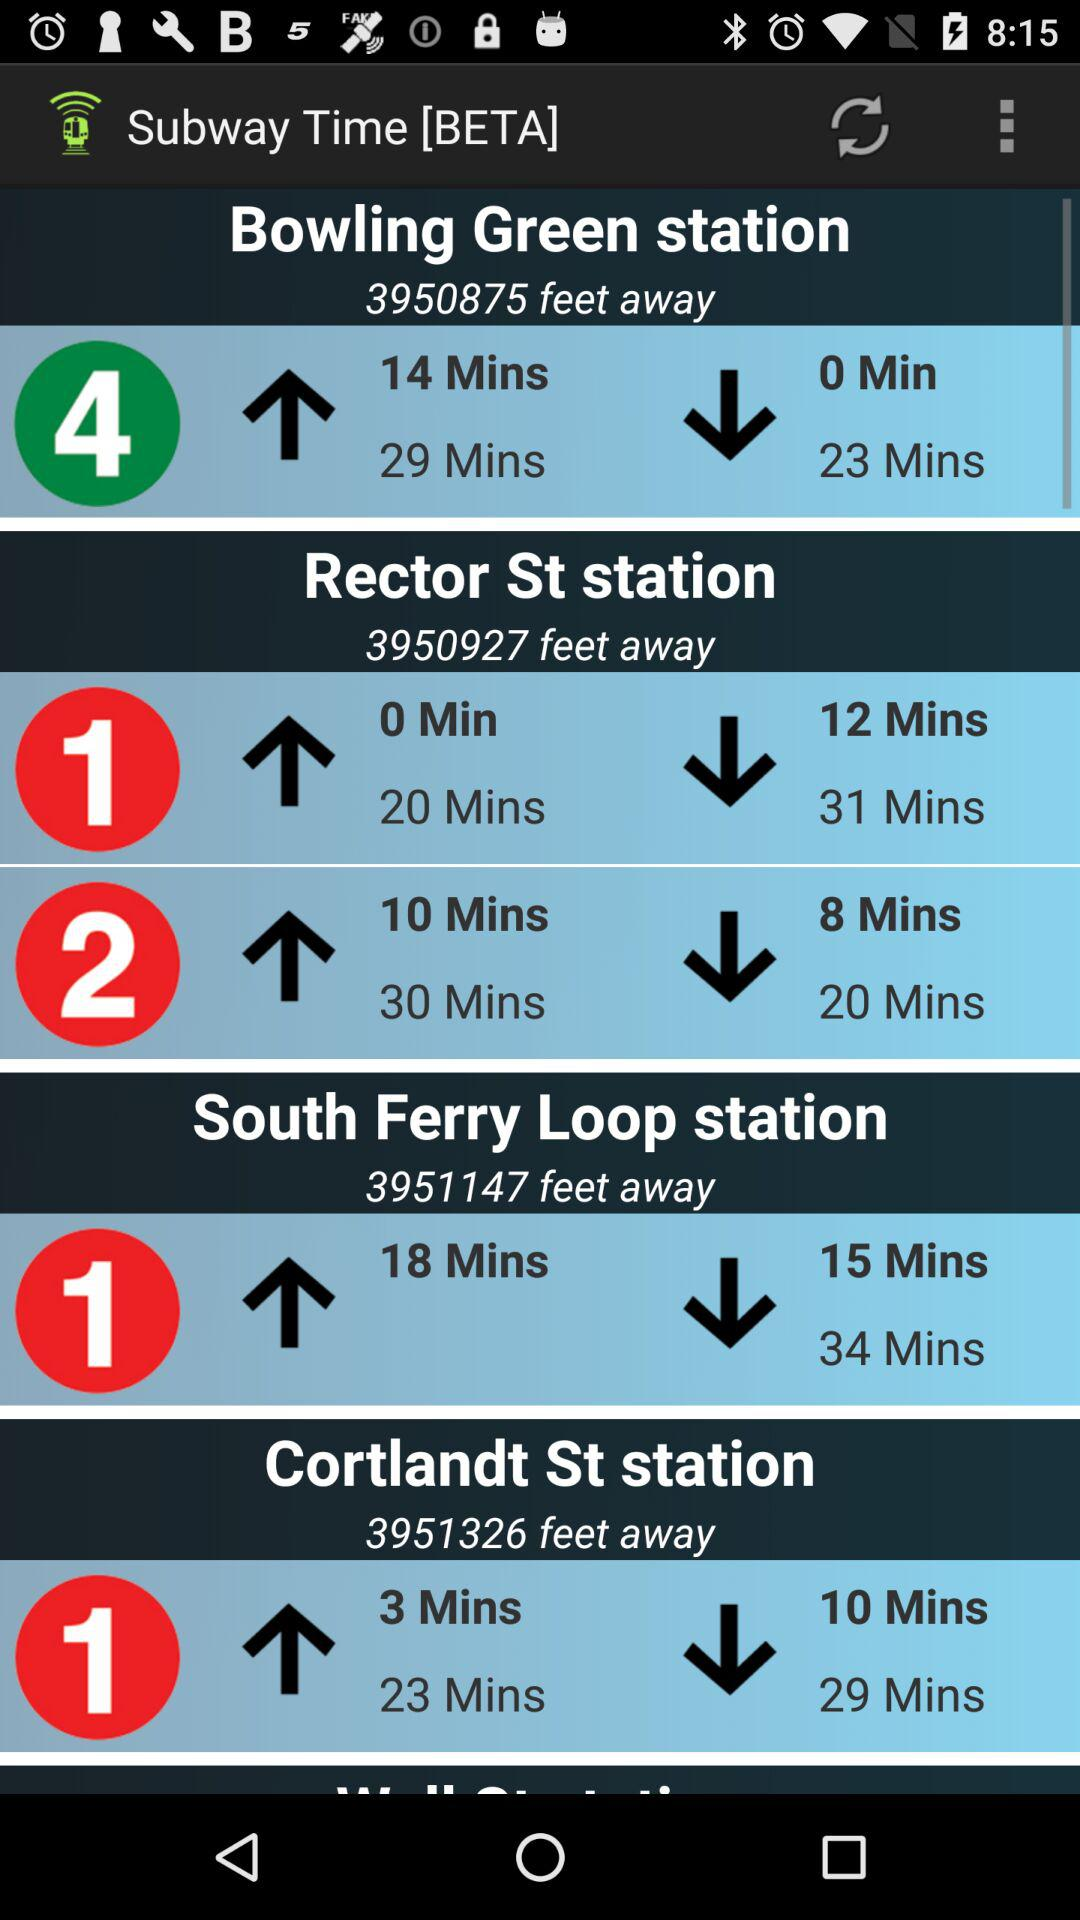How many minutes does it take to get to Cortlandt St station?
When the provided information is insufficient, respond with <no answer>. <no answer> 